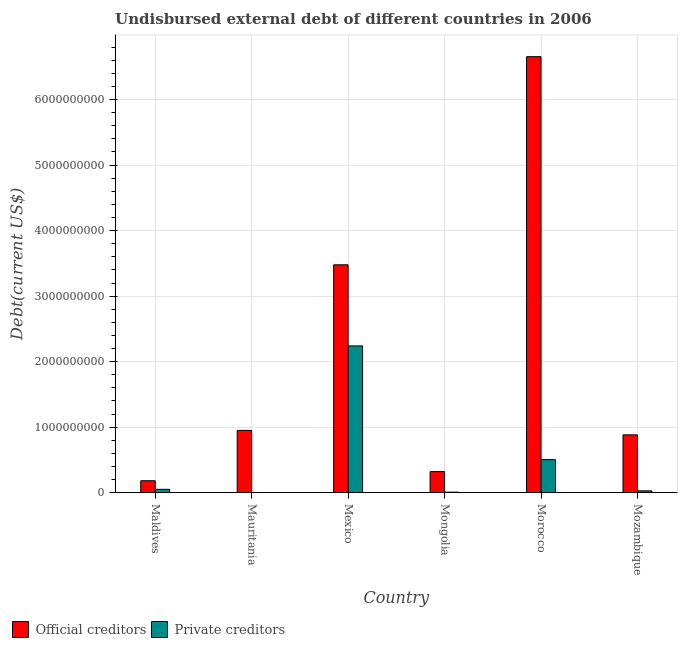How many different coloured bars are there?
Keep it short and to the point. 2. Are the number of bars on each tick of the X-axis equal?
Your answer should be very brief. Yes. How many bars are there on the 6th tick from the right?
Make the answer very short. 2. What is the label of the 4th group of bars from the left?
Give a very brief answer. Mongolia. What is the undisbursed external debt of private creditors in Mauritania?
Provide a succinct answer. 5.10e+04. Across all countries, what is the maximum undisbursed external debt of official creditors?
Keep it short and to the point. 6.65e+09. Across all countries, what is the minimum undisbursed external debt of official creditors?
Keep it short and to the point. 1.83e+08. In which country was the undisbursed external debt of private creditors minimum?
Ensure brevity in your answer.  Mauritania. What is the total undisbursed external debt of official creditors in the graph?
Provide a succinct answer. 1.25e+1. What is the difference between the undisbursed external debt of official creditors in Maldives and that in Mauritania?
Your answer should be very brief. -7.68e+08. What is the difference between the undisbursed external debt of private creditors in Maldives and the undisbursed external debt of official creditors in Mozambique?
Offer a very short reply. -8.31e+08. What is the average undisbursed external debt of private creditors per country?
Your response must be concise. 4.72e+08. What is the difference between the undisbursed external debt of private creditors and undisbursed external debt of official creditors in Maldives?
Ensure brevity in your answer.  -1.31e+08. In how many countries, is the undisbursed external debt of private creditors greater than 6600000000 US$?
Your answer should be compact. 0. What is the ratio of the undisbursed external debt of private creditors in Mexico to that in Mongolia?
Provide a succinct answer. 266.71. What is the difference between the highest and the second highest undisbursed external debt of official creditors?
Make the answer very short. 3.18e+09. What is the difference between the highest and the lowest undisbursed external debt of private creditors?
Give a very brief answer. 2.24e+09. In how many countries, is the undisbursed external debt of private creditors greater than the average undisbursed external debt of private creditors taken over all countries?
Ensure brevity in your answer.  2. What does the 1st bar from the left in Mauritania represents?
Keep it short and to the point. Official creditors. What does the 2nd bar from the right in Mexico represents?
Your response must be concise. Official creditors. Are all the bars in the graph horizontal?
Ensure brevity in your answer.  No. What is the difference between two consecutive major ticks on the Y-axis?
Your answer should be compact. 1.00e+09. Does the graph contain grids?
Make the answer very short. Yes. Where does the legend appear in the graph?
Offer a terse response. Bottom left. What is the title of the graph?
Your answer should be compact. Undisbursed external debt of different countries in 2006. What is the label or title of the Y-axis?
Offer a terse response. Debt(current US$). What is the Debt(current US$) of Official creditors in Maldives?
Keep it short and to the point. 1.83e+08. What is the Debt(current US$) of Private creditors in Maldives?
Your answer should be very brief. 5.18e+07. What is the Debt(current US$) in Official creditors in Mauritania?
Offer a very short reply. 9.51e+08. What is the Debt(current US$) of Private creditors in Mauritania?
Keep it short and to the point. 5.10e+04. What is the Debt(current US$) in Official creditors in Mexico?
Your answer should be compact. 3.48e+09. What is the Debt(current US$) of Private creditors in Mexico?
Offer a very short reply. 2.24e+09. What is the Debt(current US$) in Official creditors in Mongolia?
Offer a very short reply. 3.22e+08. What is the Debt(current US$) of Private creditors in Mongolia?
Give a very brief answer. 8.40e+06. What is the Debt(current US$) in Official creditors in Morocco?
Make the answer very short. 6.65e+09. What is the Debt(current US$) of Private creditors in Morocco?
Give a very brief answer. 5.05e+08. What is the Debt(current US$) in Official creditors in Mozambique?
Offer a terse response. 8.83e+08. What is the Debt(current US$) of Private creditors in Mozambique?
Make the answer very short. 2.85e+07. Across all countries, what is the maximum Debt(current US$) in Official creditors?
Provide a succinct answer. 6.65e+09. Across all countries, what is the maximum Debt(current US$) in Private creditors?
Make the answer very short. 2.24e+09. Across all countries, what is the minimum Debt(current US$) of Official creditors?
Provide a succinct answer. 1.83e+08. Across all countries, what is the minimum Debt(current US$) of Private creditors?
Give a very brief answer. 5.10e+04. What is the total Debt(current US$) of Official creditors in the graph?
Provide a short and direct response. 1.25e+1. What is the total Debt(current US$) of Private creditors in the graph?
Offer a terse response. 2.83e+09. What is the difference between the Debt(current US$) of Official creditors in Maldives and that in Mauritania?
Offer a terse response. -7.68e+08. What is the difference between the Debt(current US$) in Private creditors in Maldives and that in Mauritania?
Your answer should be compact. 5.17e+07. What is the difference between the Debt(current US$) of Official creditors in Maldives and that in Mexico?
Provide a succinct answer. -3.30e+09. What is the difference between the Debt(current US$) in Private creditors in Maldives and that in Mexico?
Offer a very short reply. -2.19e+09. What is the difference between the Debt(current US$) of Official creditors in Maldives and that in Mongolia?
Provide a short and direct response. -1.39e+08. What is the difference between the Debt(current US$) of Private creditors in Maldives and that in Mongolia?
Keep it short and to the point. 4.34e+07. What is the difference between the Debt(current US$) in Official creditors in Maldives and that in Morocco?
Make the answer very short. -6.47e+09. What is the difference between the Debt(current US$) of Private creditors in Maldives and that in Morocco?
Provide a short and direct response. -4.53e+08. What is the difference between the Debt(current US$) in Official creditors in Maldives and that in Mozambique?
Give a very brief answer. -7.00e+08. What is the difference between the Debt(current US$) of Private creditors in Maldives and that in Mozambique?
Give a very brief answer. 2.32e+07. What is the difference between the Debt(current US$) of Official creditors in Mauritania and that in Mexico?
Your answer should be very brief. -2.53e+09. What is the difference between the Debt(current US$) in Private creditors in Mauritania and that in Mexico?
Provide a short and direct response. -2.24e+09. What is the difference between the Debt(current US$) in Official creditors in Mauritania and that in Mongolia?
Ensure brevity in your answer.  6.29e+08. What is the difference between the Debt(current US$) in Private creditors in Mauritania and that in Mongolia?
Offer a terse response. -8.35e+06. What is the difference between the Debt(current US$) in Official creditors in Mauritania and that in Morocco?
Provide a succinct answer. -5.70e+09. What is the difference between the Debt(current US$) in Private creditors in Mauritania and that in Morocco?
Your answer should be compact. -5.05e+08. What is the difference between the Debt(current US$) in Official creditors in Mauritania and that in Mozambique?
Your answer should be compact. 6.84e+07. What is the difference between the Debt(current US$) in Private creditors in Mauritania and that in Mozambique?
Your answer should be compact. -2.85e+07. What is the difference between the Debt(current US$) in Official creditors in Mexico and that in Mongolia?
Give a very brief answer. 3.16e+09. What is the difference between the Debt(current US$) of Private creditors in Mexico and that in Mongolia?
Keep it short and to the point. 2.23e+09. What is the difference between the Debt(current US$) of Official creditors in Mexico and that in Morocco?
Offer a terse response. -3.18e+09. What is the difference between the Debt(current US$) in Private creditors in Mexico and that in Morocco?
Offer a very short reply. 1.74e+09. What is the difference between the Debt(current US$) in Official creditors in Mexico and that in Mozambique?
Provide a short and direct response. 2.60e+09. What is the difference between the Debt(current US$) of Private creditors in Mexico and that in Mozambique?
Keep it short and to the point. 2.21e+09. What is the difference between the Debt(current US$) of Official creditors in Mongolia and that in Morocco?
Offer a terse response. -6.33e+09. What is the difference between the Debt(current US$) in Private creditors in Mongolia and that in Morocco?
Ensure brevity in your answer.  -4.96e+08. What is the difference between the Debt(current US$) of Official creditors in Mongolia and that in Mozambique?
Offer a very short reply. -5.61e+08. What is the difference between the Debt(current US$) in Private creditors in Mongolia and that in Mozambique?
Offer a terse response. -2.01e+07. What is the difference between the Debt(current US$) in Official creditors in Morocco and that in Mozambique?
Ensure brevity in your answer.  5.77e+09. What is the difference between the Debt(current US$) of Private creditors in Morocco and that in Mozambique?
Provide a succinct answer. 4.76e+08. What is the difference between the Debt(current US$) in Official creditors in Maldives and the Debt(current US$) in Private creditors in Mauritania?
Provide a short and direct response. 1.83e+08. What is the difference between the Debt(current US$) of Official creditors in Maldives and the Debt(current US$) of Private creditors in Mexico?
Provide a short and direct response. -2.06e+09. What is the difference between the Debt(current US$) of Official creditors in Maldives and the Debt(current US$) of Private creditors in Mongolia?
Your answer should be very brief. 1.74e+08. What is the difference between the Debt(current US$) of Official creditors in Maldives and the Debt(current US$) of Private creditors in Morocco?
Offer a terse response. -3.22e+08. What is the difference between the Debt(current US$) in Official creditors in Maldives and the Debt(current US$) in Private creditors in Mozambique?
Provide a succinct answer. 1.54e+08. What is the difference between the Debt(current US$) in Official creditors in Mauritania and the Debt(current US$) in Private creditors in Mexico?
Your answer should be compact. -1.29e+09. What is the difference between the Debt(current US$) in Official creditors in Mauritania and the Debt(current US$) in Private creditors in Mongolia?
Make the answer very short. 9.43e+08. What is the difference between the Debt(current US$) in Official creditors in Mauritania and the Debt(current US$) in Private creditors in Morocco?
Ensure brevity in your answer.  4.46e+08. What is the difference between the Debt(current US$) of Official creditors in Mauritania and the Debt(current US$) of Private creditors in Mozambique?
Offer a terse response. 9.23e+08. What is the difference between the Debt(current US$) of Official creditors in Mexico and the Debt(current US$) of Private creditors in Mongolia?
Give a very brief answer. 3.47e+09. What is the difference between the Debt(current US$) in Official creditors in Mexico and the Debt(current US$) in Private creditors in Morocco?
Ensure brevity in your answer.  2.97e+09. What is the difference between the Debt(current US$) of Official creditors in Mexico and the Debt(current US$) of Private creditors in Mozambique?
Your answer should be compact. 3.45e+09. What is the difference between the Debt(current US$) of Official creditors in Mongolia and the Debt(current US$) of Private creditors in Morocco?
Your answer should be compact. -1.83e+08. What is the difference between the Debt(current US$) in Official creditors in Mongolia and the Debt(current US$) in Private creditors in Mozambique?
Provide a succinct answer. 2.94e+08. What is the difference between the Debt(current US$) in Official creditors in Morocco and the Debt(current US$) in Private creditors in Mozambique?
Make the answer very short. 6.63e+09. What is the average Debt(current US$) in Official creditors per country?
Ensure brevity in your answer.  2.08e+09. What is the average Debt(current US$) in Private creditors per country?
Make the answer very short. 4.72e+08. What is the difference between the Debt(current US$) in Official creditors and Debt(current US$) in Private creditors in Maldives?
Keep it short and to the point. 1.31e+08. What is the difference between the Debt(current US$) in Official creditors and Debt(current US$) in Private creditors in Mauritania?
Your answer should be very brief. 9.51e+08. What is the difference between the Debt(current US$) in Official creditors and Debt(current US$) in Private creditors in Mexico?
Offer a terse response. 1.24e+09. What is the difference between the Debt(current US$) of Official creditors and Debt(current US$) of Private creditors in Mongolia?
Provide a succinct answer. 3.14e+08. What is the difference between the Debt(current US$) in Official creditors and Debt(current US$) in Private creditors in Morocco?
Offer a terse response. 6.15e+09. What is the difference between the Debt(current US$) in Official creditors and Debt(current US$) in Private creditors in Mozambique?
Offer a very short reply. 8.54e+08. What is the ratio of the Debt(current US$) of Official creditors in Maldives to that in Mauritania?
Give a very brief answer. 0.19. What is the ratio of the Debt(current US$) of Private creditors in Maldives to that in Mauritania?
Make the answer very short. 1014.96. What is the ratio of the Debt(current US$) in Official creditors in Maldives to that in Mexico?
Provide a succinct answer. 0.05. What is the ratio of the Debt(current US$) of Private creditors in Maldives to that in Mexico?
Ensure brevity in your answer.  0.02. What is the ratio of the Debt(current US$) of Official creditors in Maldives to that in Mongolia?
Offer a very short reply. 0.57. What is the ratio of the Debt(current US$) of Private creditors in Maldives to that in Mongolia?
Your answer should be very brief. 6.16. What is the ratio of the Debt(current US$) in Official creditors in Maldives to that in Morocco?
Offer a very short reply. 0.03. What is the ratio of the Debt(current US$) of Private creditors in Maldives to that in Morocco?
Give a very brief answer. 0.1. What is the ratio of the Debt(current US$) of Official creditors in Maldives to that in Mozambique?
Provide a short and direct response. 0.21. What is the ratio of the Debt(current US$) in Private creditors in Maldives to that in Mozambique?
Give a very brief answer. 1.81. What is the ratio of the Debt(current US$) in Official creditors in Mauritania to that in Mexico?
Offer a very short reply. 0.27. What is the ratio of the Debt(current US$) in Official creditors in Mauritania to that in Mongolia?
Offer a very short reply. 2.95. What is the ratio of the Debt(current US$) of Private creditors in Mauritania to that in Mongolia?
Provide a succinct answer. 0.01. What is the ratio of the Debt(current US$) of Official creditors in Mauritania to that in Morocco?
Offer a very short reply. 0.14. What is the ratio of the Debt(current US$) of Private creditors in Mauritania to that in Morocco?
Make the answer very short. 0. What is the ratio of the Debt(current US$) in Official creditors in Mauritania to that in Mozambique?
Your answer should be compact. 1.08. What is the ratio of the Debt(current US$) in Private creditors in Mauritania to that in Mozambique?
Keep it short and to the point. 0. What is the ratio of the Debt(current US$) in Official creditors in Mexico to that in Mongolia?
Ensure brevity in your answer.  10.8. What is the ratio of the Debt(current US$) in Private creditors in Mexico to that in Mongolia?
Provide a succinct answer. 266.71. What is the ratio of the Debt(current US$) in Official creditors in Mexico to that in Morocco?
Keep it short and to the point. 0.52. What is the ratio of the Debt(current US$) in Private creditors in Mexico to that in Morocco?
Your response must be concise. 4.44. What is the ratio of the Debt(current US$) in Official creditors in Mexico to that in Mozambique?
Offer a terse response. 3.94. What is the ratio of the Debt(current US$) in Private creditors in Mexico to that in Mozambique?
Offer a very short reply. 78.54. What is the ratio of the Debt(current US$) of Official creditors in Mongolia to that in Morocco?
Your answer should be compact. 0.05. What is the ratio of the Debt(current US$) of Private creditors in Mongolia to that in Morocco?
Your answer should be compact. 0.02. What is the ratio of the Debt(current US$) of Official creditors in Mongolia to that in Mozambique?
Make the answer very short. 0.36. What is the ratio of the Debt(current US$) of Private creditors in Mongolia to that in Mozambique?
Give a very brief answer. 0.29. What is the ratio of the Debt(current US$) of Official creditors in Morocco to that in Mozambique?
Make the answer very short. 7.54. What is the ratio of the Debt(current US$) in Private creditors in Morocco to that in Mozambique?
Ensure brevity in your answer.  17.69. What is the difference between the highest and the second highest Debt(current US$) in Official creditors?
Provide a succinct answer. 3.18e+09. What is the difference between the highest and the second highest Debt(current US$) of Private creditors?
Keep it short and to the point. 1.74e+09. What is the difference between the highest and the lowest Debt(current US$) in Official creditors?
Your answer should be compact. 6.47e+09. What is the difference between the highest and the lowest Debt(current US$) of Private creditors?
Your answer should be compact. 2.24e+09. 